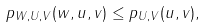<formula> <loc_0><loc_0><loc_500><loc_500>p _ { W , U , V } ( w , u , v ) \leq p _ { U , V } ( u , v ) ,</formula> 